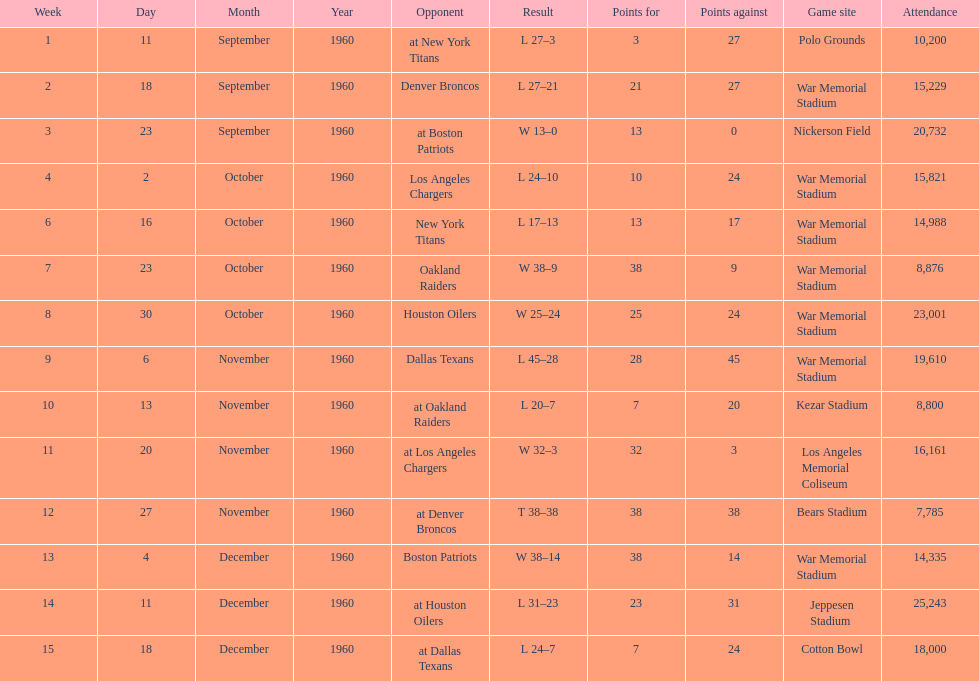How many games had an attendance of 10,000 at most? 11. 